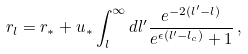Convert formula to latex. <formula><loc_0><loc_0><loc_500><loc_500>r _ { l } = r _ { \ast } + u _ { \ast } \int _ { l } ^ { \infty } d l ^ { \prime } \frac { e ^ { - 2 ( l ^ { \prime } - l ) } } { e ^ { \epsilon ( l ^ { \prime } - l _ { c } ) } + 1 } \, ,</formula> 